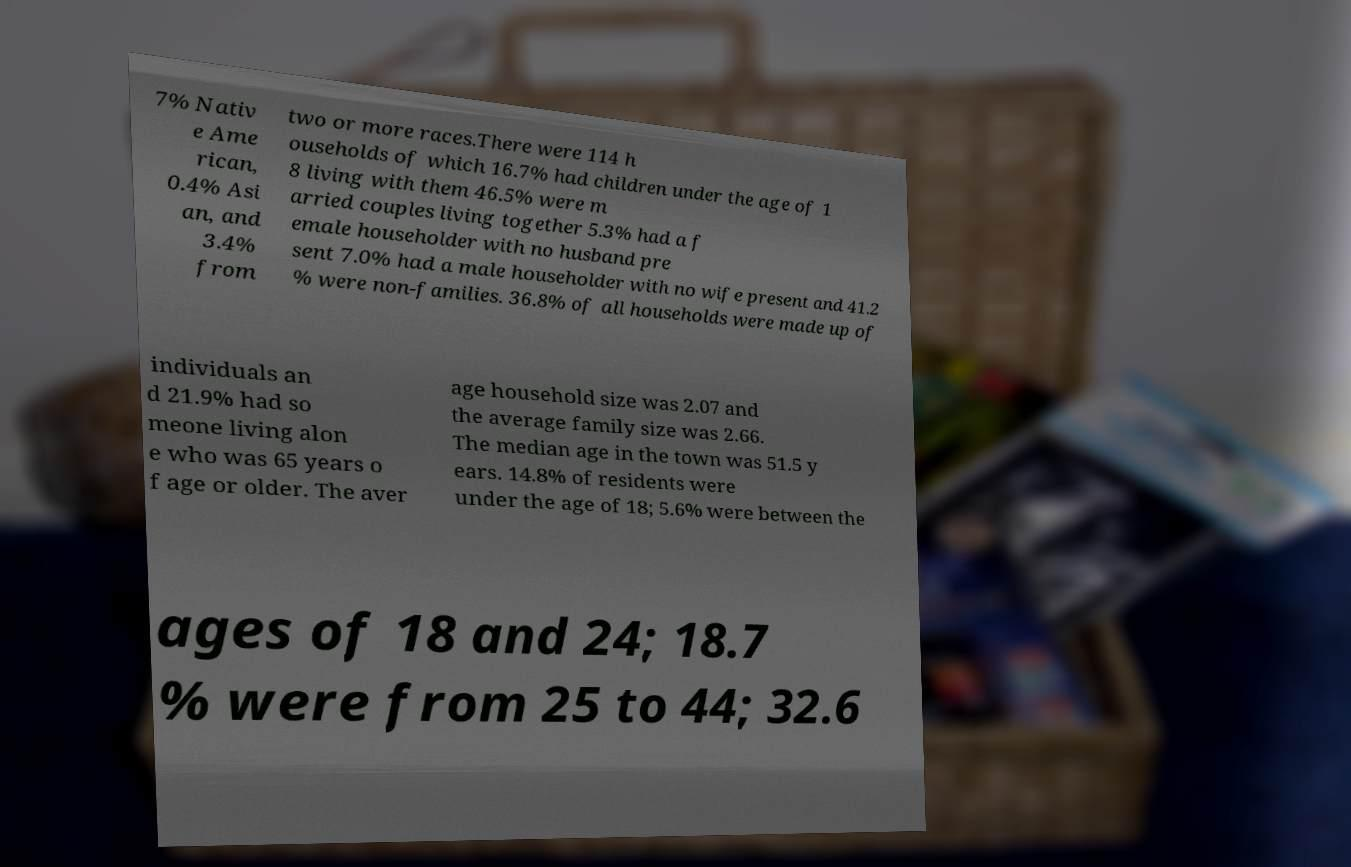I need the written content from this picture converted into text. Can you do that? 7% Nativ e Ame rican, 0.4% Asi an, and 3.4% from two or more races.There were 114 h ouseholds of which 16.7% had children under the age of 1 8 living with them 46.5% were m arried couples living together 5.3% had a f emale householder with no husband pre sent 7.0% had a male householder with no wife present and 41.2 % were non-families. 36.8% of all households were made up of individuals an d 21.9% had so meone living alon e who was 65 years o f age or older. The aver age household size was 2.07 and the average family size was 2.66. The median age in the town was 51.5 y ears. 14.8% of residents were under the age of 18; 5.6% were between the ages of 18 and 24; 18.7 % were from 25 to 44; 32.6 